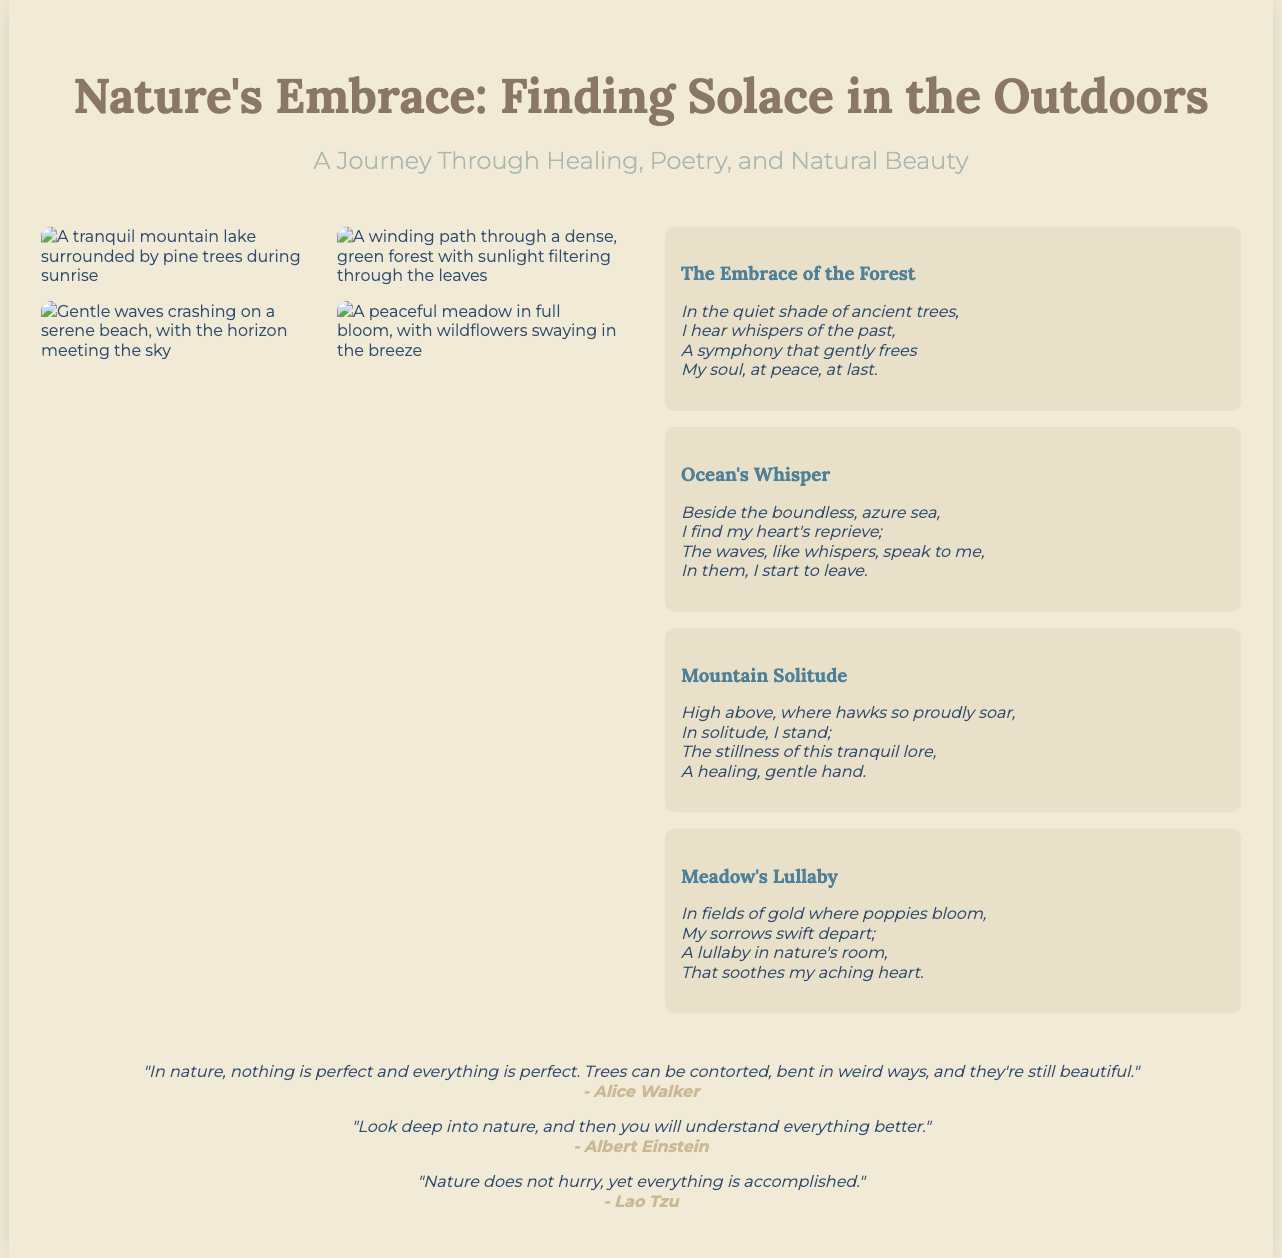What is the title of the poster? The title is prominently displayed at the top of the poster, stating the theme of the document.
Answer: Nature's Embrace: Finding Solace in the Outdoors How many poems are included in the poetry section? The document includes four distinct poems in the poetry section, with each poem featuring a unique title and text.
Answer: 4 Which quote is attributed to Albert Einstein? The document includes a quote from Albert Einstein about nature, which is clearly referenced under his name.
Answer: "Look deep into nature, and then you will understand everything better." What imagery is featured in the visual section? The visual section contains images that depict various natural landscapes, captured in serene and beautiful moments.
Answer: Mountain lake, forest path, ocean waves, quiet meadow What colors dominate the poster’s design? The overall color scheme comprises earth tones and tones that evoke a serene, tranquil feeling, aligned with the theme of nature.
Answer: Earth tones What theme does the poetry convey? The poems included on the poster express feelings of healing and tranquility associated with nature, encapsulating a journey of solace.
Answer: Solace and tranquility in nature What visual element enhances the poster's appeal? The poster utilizes stunning visuals of natural landscapes that complement the poetic text, creating an inviting and calming atmosphere.
Answer: Stunning visuals of natural landscapes What is the purpose of the quoted text included in the poster? The quoted text serves to inspire and reflect on the relationship between nature and human experience, enhancing the overall message of the poster.
Answer: Inspire reflection on nature 